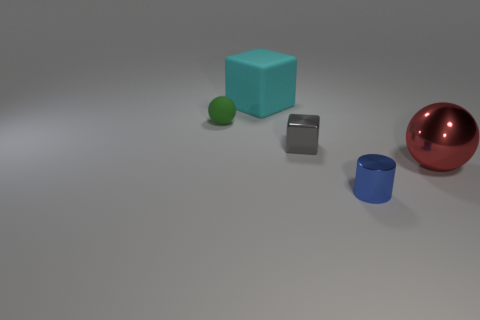Subtract all gray spheres. Subtract all blue blocks. How many spheres are left? 2 Add 1 small green balls. How many objects exist? 6 Subtract all spheres. How many objects are left? 3 Add 5 big metal spheres. How many big metal spheres exist? 6 Subtract 0 red cubes. How many objects are left? 5 Subtract all tiny brown metallic cylinders. Subtract all green matte objects. How many objects are left? 4 Add 4 metal cylinders. How many metal cylinders are left? 5 